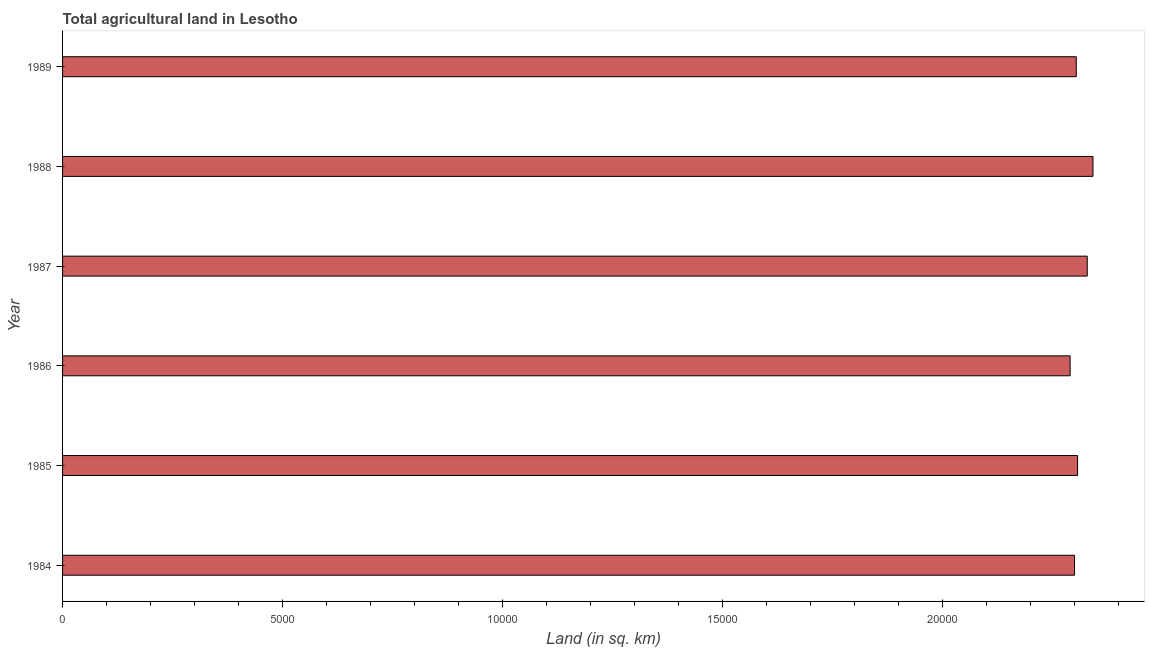Does the graph contain grids?
Your response must be concise. No. What is the title of the graph?
Your response must be concise. Total agricultural land in Lesotho. What is the label or title of the X-axis?
Give a very brief answer. Land (in sq. km). What is the agricultural land in 1988?
Keep it short and to the point. 2.34e+04. Across all years, what is the maximum agricultural land?
Offer a terse response. 2.34e+04. Across all years, what is the minimum agricultural land?
Keep it short and to the point. 2.29e+04. In which year was the agricultural land maximum?
Ensure brevity in your answer.  1988. In which year was the agricultural land minimum?
Your answer should be very brief. 1986. What is the sum of the agricultural land?
Keep it short and to the point. 1.39e+05. What is the difference between the agricultural land in 1985 and 1988?
Provide a succinct answer. -350. What is the average agricultural land per year?
Give a very brief answer. 2.31e+04. What is the median agricultural land?
Ensure brevity in your answer.  2.31e+04. In how many years, is the agricultural land greater than 14000 sq. km?
Your answer should be very brief. 6. Do a majority of the years between 1987 and 1989 (inclusive) have agricultural land greater than 14000 sq. km?
Give a very brief answer. Yes. What is the difference between the highest and the second highest agricultural land?
Give a very brief answer. 130. What is the difference between the highest and the lowest agricultural land?
Keep it short and to the point. 520. How many bars are there?
Give a very brief answer. 6. How many years are there in the graph?
Give a very brief answer. 6. What is the Land (in sq. km) in 1984?
Your answer should be compact. 2.30e+04. What is the Land (in sq. km) of 1985?
Your answer should be very brief. 2.31e+04. What is the Land (in sq. km) in 1986?
Ensure brevity in your answer.  2.29e+04. What is the Land (in sq. km) in 1987?
Offer a very short reply. 2.33e+04. What is the Land (in sq. km) in 1988?
Your answer should be compact. 2.34e+04. What is the Land (in sq. km) of 1989?
Keep it short and to the point. 2.30e+04. What is the difference between the Land (in sq. km) in 1984 and 1985?
Offer a terse response. -70. What is the difference between the Land (in sq. km) in 1984 and 1987?
Provide a succinct answer. -290. What is the difference between the Land (in sq. km) in 1984 and 1988?
Keep it short and to the point. -420. What is the difference between the Land (in sq. km) in 1985 and 1986?
Keep it short and to the point. 170. What is the difference between the Land (in sq. km) in 1985 and 1987?
Your answer should be very brief. -220. What is the difference between the Land (in sq. km) in 1985 and 1988?
Offer a very short reply. -350. What is the difference between the Land (in sq. km) in 1985 and 1989?
Provide a succinct answer. 30. What is the difference between the Land (in sq. km) in 1986 and 1987?
Your answer should be compact. -390. What is the difference between the Land (in sq. km) in 1986 and 1988?
Offer a terse response. -520. What is the difference between the Land (in sq. km) in 1986 and 1989?
Offer a terse response. -140. What is the difference between the Land (in sq. km) in 1987 and 1988?
Ensure brevity in your answer.  -130. What is the difference between the Land (in sq. km) in 1987 and 1989?
Offer a very short reply. 250. What is the difference between the Land (in sq. km) in 1988 and 1989?
Provide a succinct answer. 380. What is the ratio of the Land (in sq. km) in 1984 to that in 1985?
Give a very brief answer. 1. What is the ratio of the Land (in sq. km) in 1984 to that in 1986?
Make the answer very short. 1. What is the ratio of the Land (in sq. km) in 1984 to that in 1987?
Make the answer very short. 0.99. What is the ratio of the Land (in sq. km) in 1984 to that in 1988?
Your answer should be very brief. 0.98. What is the ratio of the Land (in sq. km) in 1985 to that in 1988?
Your answer should be very brief. 0.98. What is the ratio of the Land (in sq. km) in 1985 to that in 1989?
Make the answer very short. 1. What is the ratio of the Land (in sq. km) in 1986 to that in 1987?
Offer a very short reply. 0.98. What is the ratio of the Land (in sq. km) in 1986 to that in 1988?
Provide a short and direct response. 0.98. What is the ratio of the Land (in sq. km) in 1986 to that in 1989?
Offer a very short reply. 0.99. What is the ratio of the Land (in sq. km) in 1988 to that in 1989?
Provide a succinct answer. 1.02. 